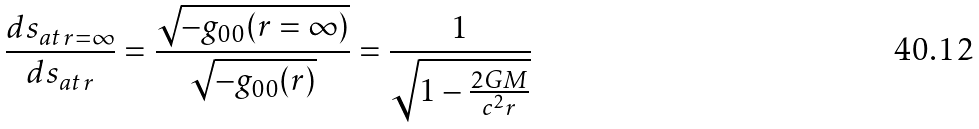Convert formula to latex. <formula><loc_0><loc_0><loc_500><loc_500>\frac { d s _ { a t \, r = \infty } } { d s _ { a t \, r } } = \frac { \sqrt { - g _ { 0 0 } ( r = \infty ) } } { \sqrt { - g _ { 0 0 } ( r ) } } = \frac { 1 } { \sqrt { 1 - \frac { 2 G M } { c ^ { 2 } r } } }</formula> 